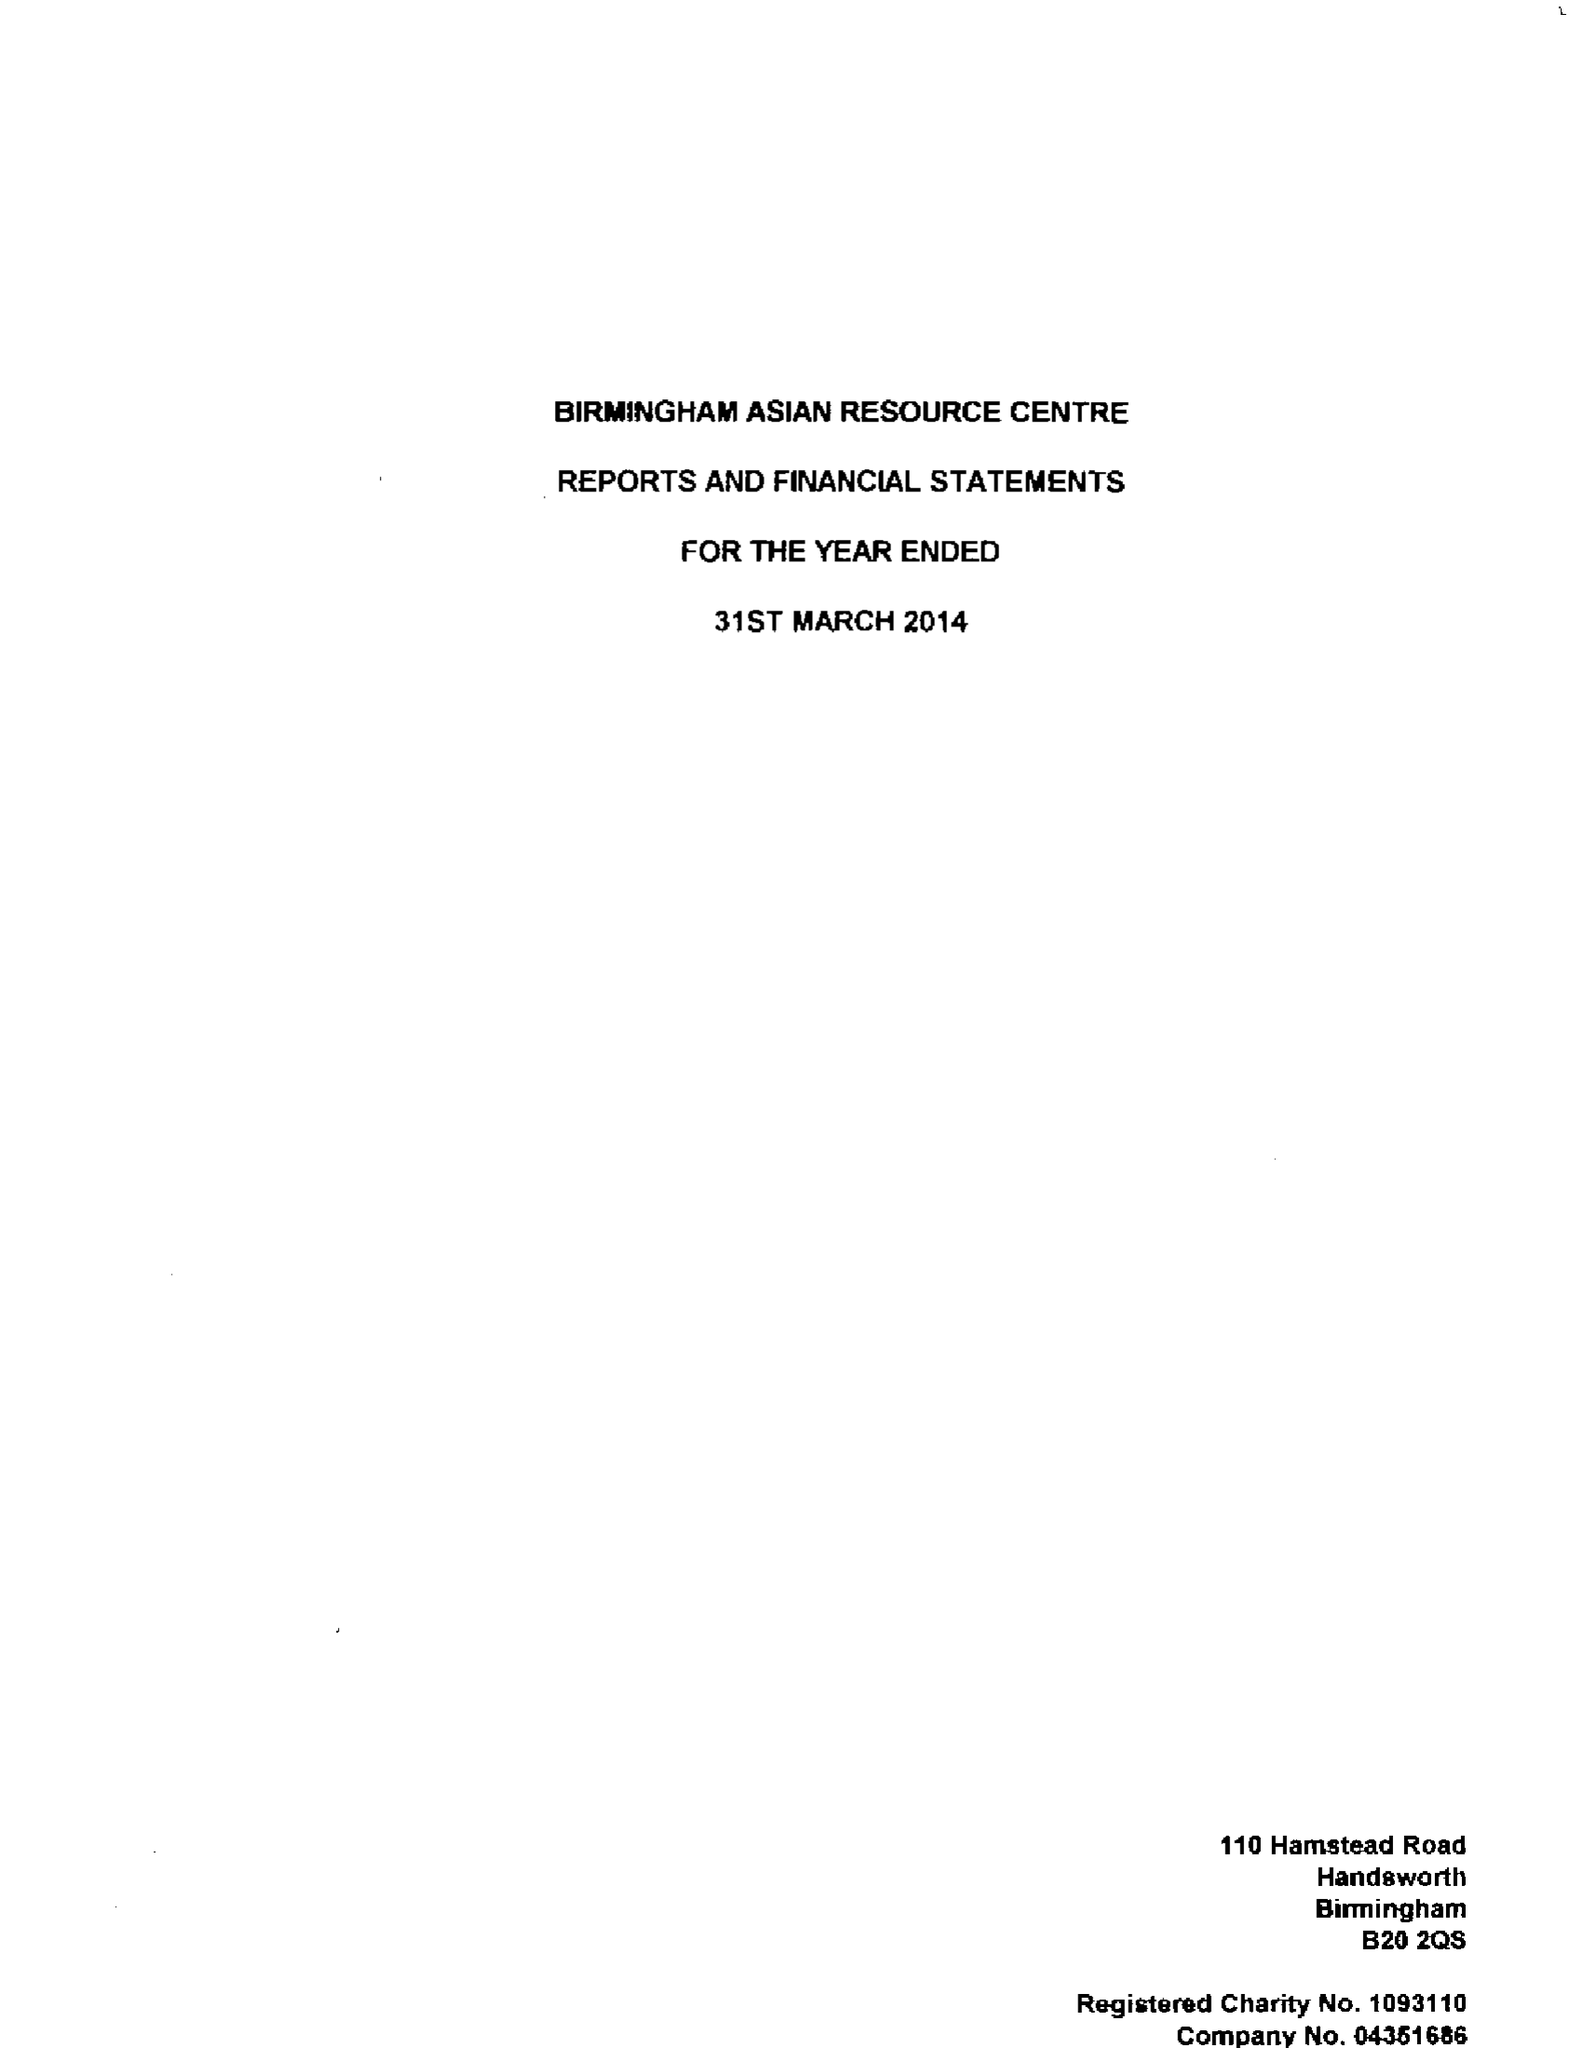What is the value for the charity_number?
Answer the question using a single word or phrase. 1093110 